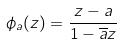<formula> <loc_0><loc_0><loc_500><loc_500>\phi _ { a } ( z ) = \frac { z - a } { 1 - \overline { a } z }</formula> 